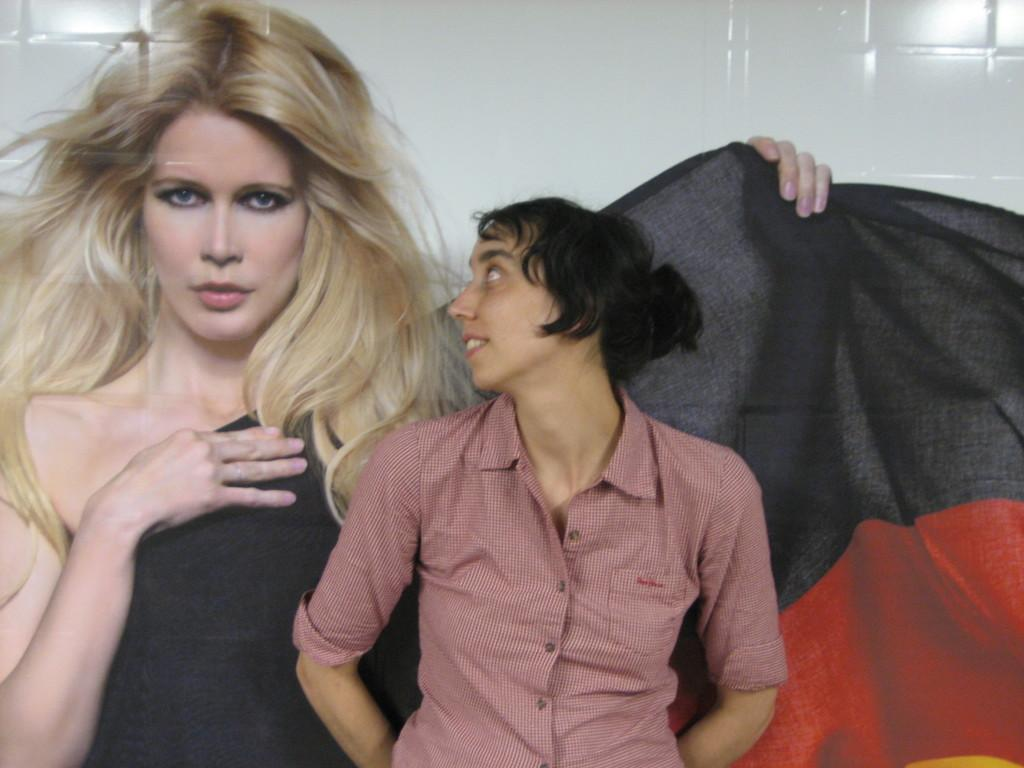What is the main subject in the middle of the image? There is a woman standing in the middle of the image. What is the woman wearing? The woman is wearing a shirt. What can be seen on the left side of the image? There is a picture of a woman on the left side of the image. What is the woman in the picture wearing? The woman in the picture is wearing a black dress. What color is the wall visible in the background of the image? The wall visible in the background of the image is white. What type of teaching is the woman in the image providing? There is no indication in the image that the woman is teaching or providing any educational instruction. 